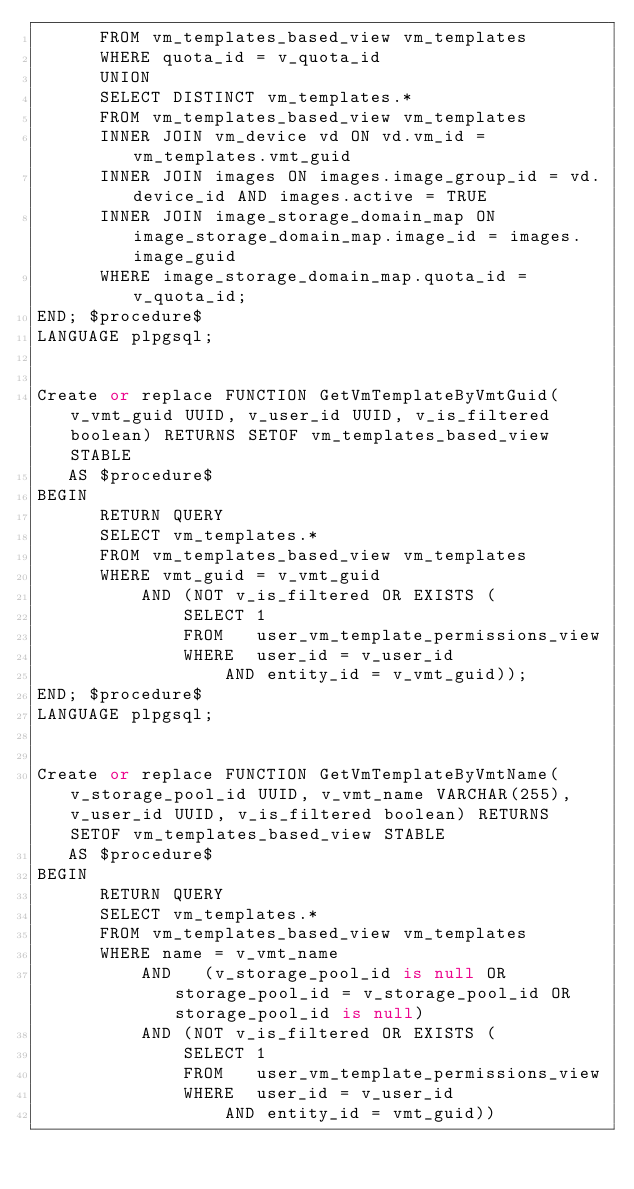Convert code to text. <code><loc_0><loc_0><loc_500><loc_500><_SQL_>      FROM vm_templates_based_view vm_templates
      WHERE quota_id = v_quota_id
      UNION
      SELECT DISTINCT vm_templates.*
      FROM vm_templates_based_view vm_templates
      INNER JOIN vm_device vd ON vd.vm_id = vm_templates.vmt_guid
      INNER JOIN images ON images.image_group_id = vd.device_id AND images.active = TRUE
      INNER JOIN image_storage_domain_map ON image_storage_domain_map.image_id = images.image_guid
      WHERE image_storage_domain_map.quota_id = v_quota_id;
END; $procedure$
LANGUAGE plpgsql;


Create or replace FUNCTION GetVmTemplateByVmtGuid(v_vmt_guid UUID, v_user_id UUID, v_is_filtered boolean) RETURNS SETOF vm_templates_based_view STABLE
   AS $procedure$
BEGIN
      RETURN QUERY
      SELECT vm_templates.*
      FROM vm_templates_based_view vm_templates
      WHERE vmt_guid = v_vmt_guid
          AND (NOT v_is_filtered OR EXISTS (
              SELECT 1
              FROM   user_vm_template_permissions_view
              WHERE  user_id = v_user_id
                  AND entity_id = v_vmt_guid));
END; $procedure$
LANGUAGE plpgsql;


Create or replace FUNCTION GetVmTemplateByVmtName(v_storage_pool_id UUID, v_vmt_name VARCHAR(255), v_user_id UUID, v_is_filtered boolean) RETURNS SETOF vm_templates_based_view STABLE
   AS $procedure$
BEGIN
      RETURN QUERY
      SELECT vm_templates.*
      FROM vm_templates_based_view vm_templates
      WHERE name = v_vmt_name
          AND   (v_storage_pool_id is null OR storage_pool_id = v_storage_pool_id OR storage_pool_id is null)
          AND (NOT v_is_filtered OR EXISTS (
              SELECT 1
              FROM   user_vm_template_permissions_view
              WHERE  user_id = v_user_id
                  AND entity_id = vmt_guid))</code> 